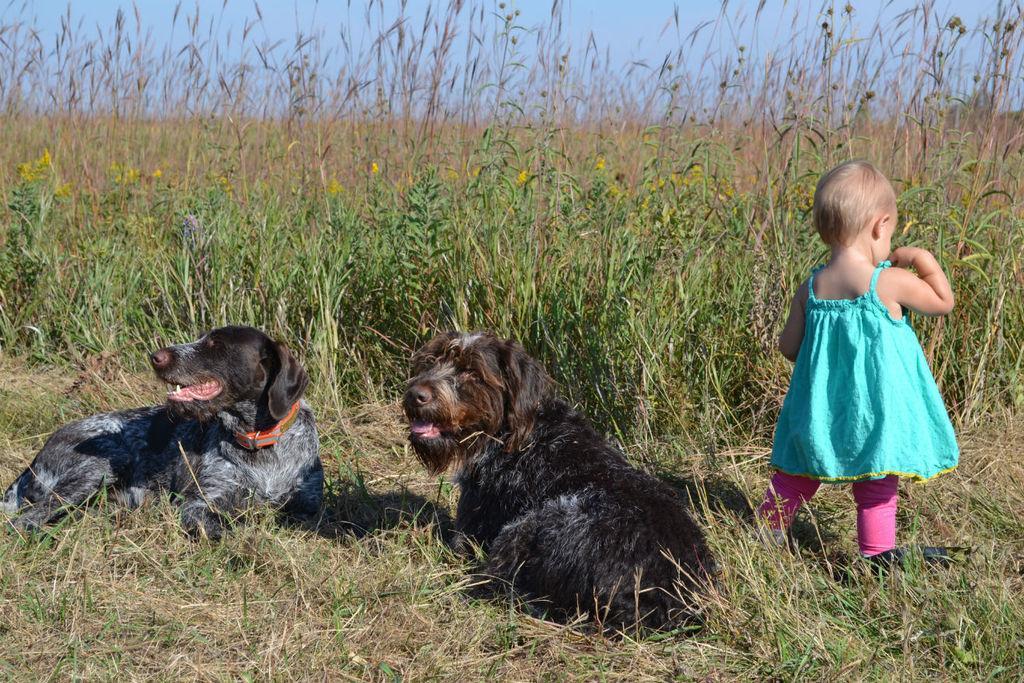Could you give a brief overview of what you see in this image? In this image we can see dogs sitting on the grass. On the right there is a girl standing. In the background there is a field and sky. 